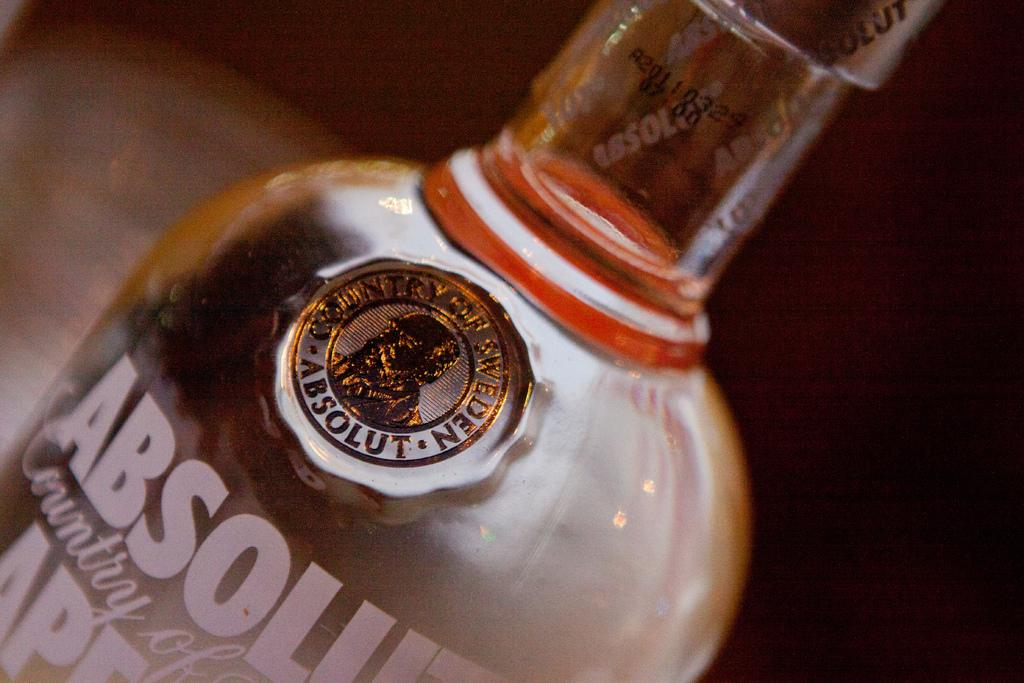<image>
Create a compact narrative representing the image presented. Absolut Vodka is a product of the Country of Sweden. 